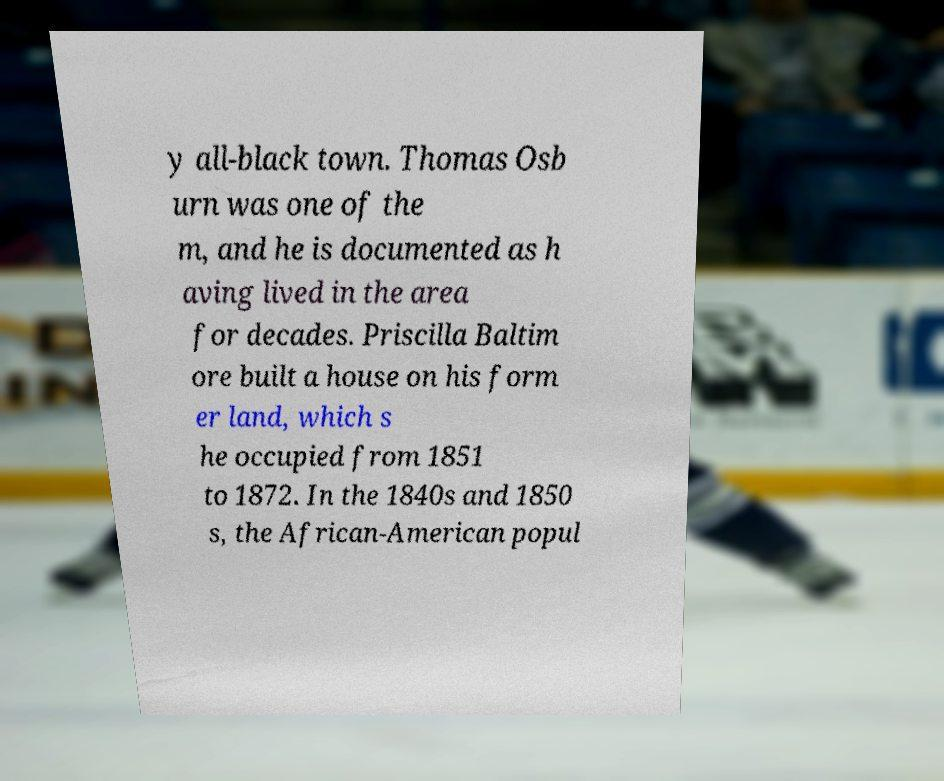Could you extract and type out the text from this image? y all-black town. Thomas Osb urn was one of the m, and he is documented as h aving lived in the area for decades. Priscilla Baltim ore built a house on his form er land, which s he occupied from 1851 to 1872. In the 1840s and 1850 s, the African-American popul 